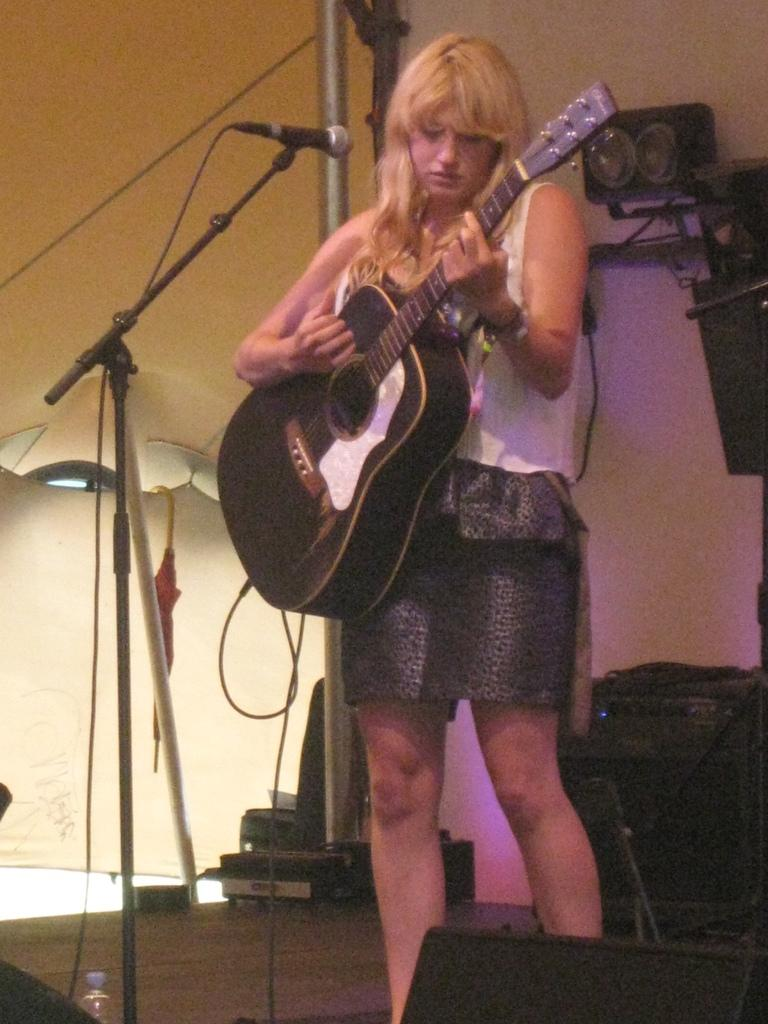Who is the main subject in the image? There is a woman in the image. What is the woman standing on? The woman is standing on a wooden floor. What is the woman doing in the image? The woman is playing a guitar. What object is present in the image that is typically used for amplifying sound? There is a microphone on a stand in the image. Can you see the coach in the image? There is no coach present in the image. Is there a ghost visible in the image? There is no ghost visible in the image. 